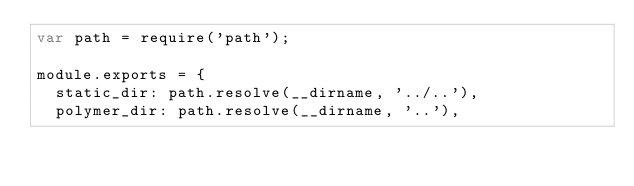Convert code to text. <code><loc_0><loc_0><loc_500><loc_500><_JavaScript_>var path = require('path');

module.exports = {
  static_dir: path.resolve(__dirname, '../..'),
  polymer_dir: path.resolve(__dirname, '..'),</code> 